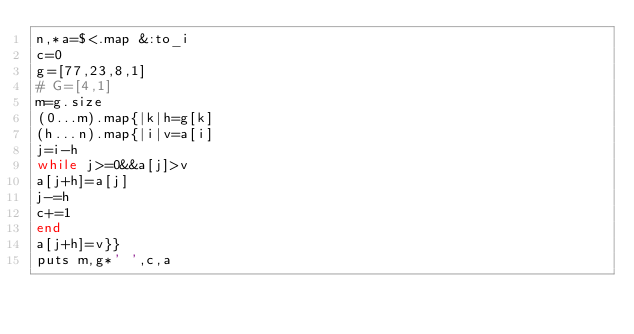<code> <loc_0><loc_0><loc_500><loc_500><_Ruby_>n,*a=$<.map &:to_i
c=0
g=[77,23,8,1]
# G=[4,1]
m=g.size
(0...m).map{|k|h=g[k]
(h...n).map{|i|v=a[i]
j=i-h
while j>=0&&a[j]>v
a[j+h]=a[j]
j-=h
c+=1
end
a[j+h]=v}}
puts m,g*' ',c,a</code> 